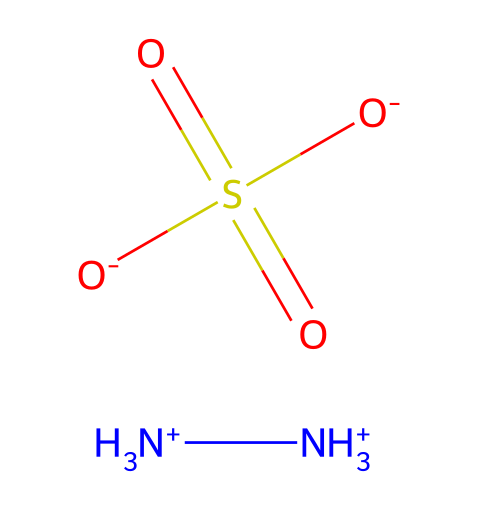What is the molecular formula of this compound? The SMILES representation indicates that this chemical contains two nitrogen (N) atoms, one sulfur (S) atom, and four oxygen (O) atoms along with the associated hydrogens. Therefore, the molecular formula is derived from counting these atoms.
Answer: N2H8O4S How many nitrogen atoms are present in this chemical? By analyzing the SMILES representation, we see that there are two [NH3+] units, each contributing one nitrogen atom. The total count of nitrogen atoms is two.
Answer: 2 What type of functional group is present in this compound? The structure contains a sulfonate group, which is indicated by the -S(=O)(=O) portion of the SMILES. This signifies the presence of sulfur bonded to three oxygen atoms in a specific arrangement, characteristic of sulfonates.
Answer: sulfonate Are there any acidic components in this compound? In the SMILES representation, the presence of -SO3- (sulfonate) suggests that the compound has acidic properties, as sulfonates can release protons in solution. Hence, this compound does contain acidic components.
Answer: yes What is the charge of this compound? The SMILES notation shows two ammonium ions ([NH3+]), each with a positive charge, and one sulfonate group (O-), which carries a negative charge. Thus, the total charge can be evaluated as +2 from the nitrogen minus 1 from the sulfur, resulting in a net charge of +1.
Answer: +1 Is hydrazine sulfate used in any medicinal applications? Given the context of the chemical structure and its designation as a sulfate derivative of hydrazine, this compound is indeed discussed in relation to various medicinal uses, although its classification as a dietary supplement can be controversial.
Answer: yes 